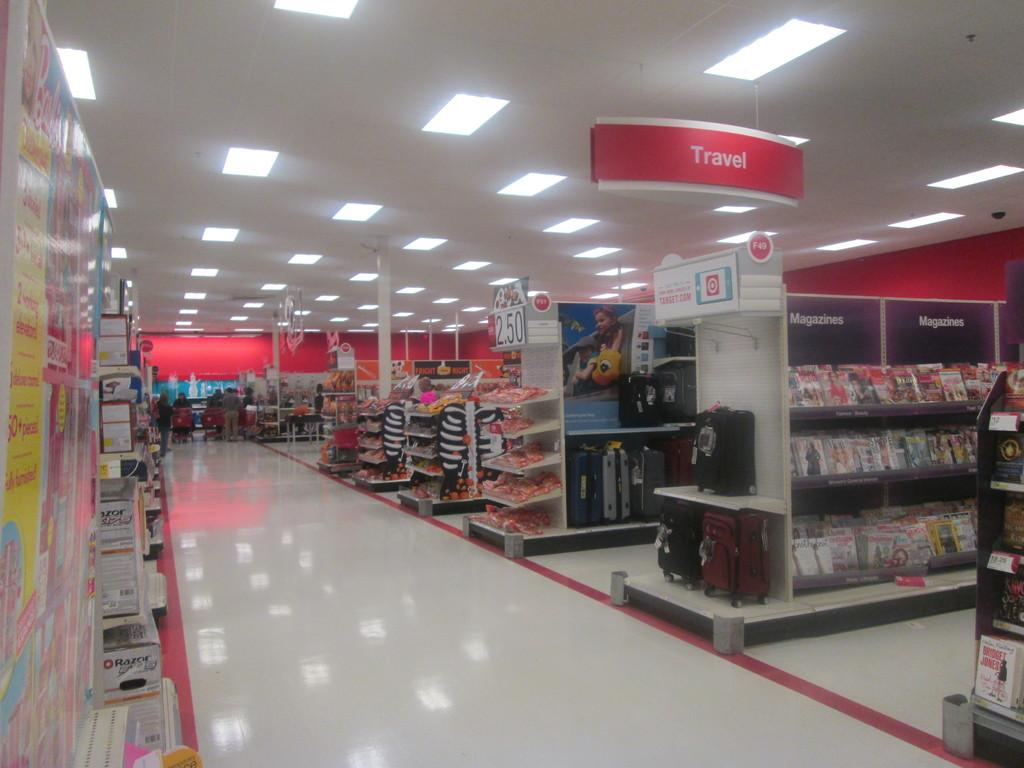<image>
Create a compact narrative representing the image presented. A store with different items such as Magazines and a Travel section. 